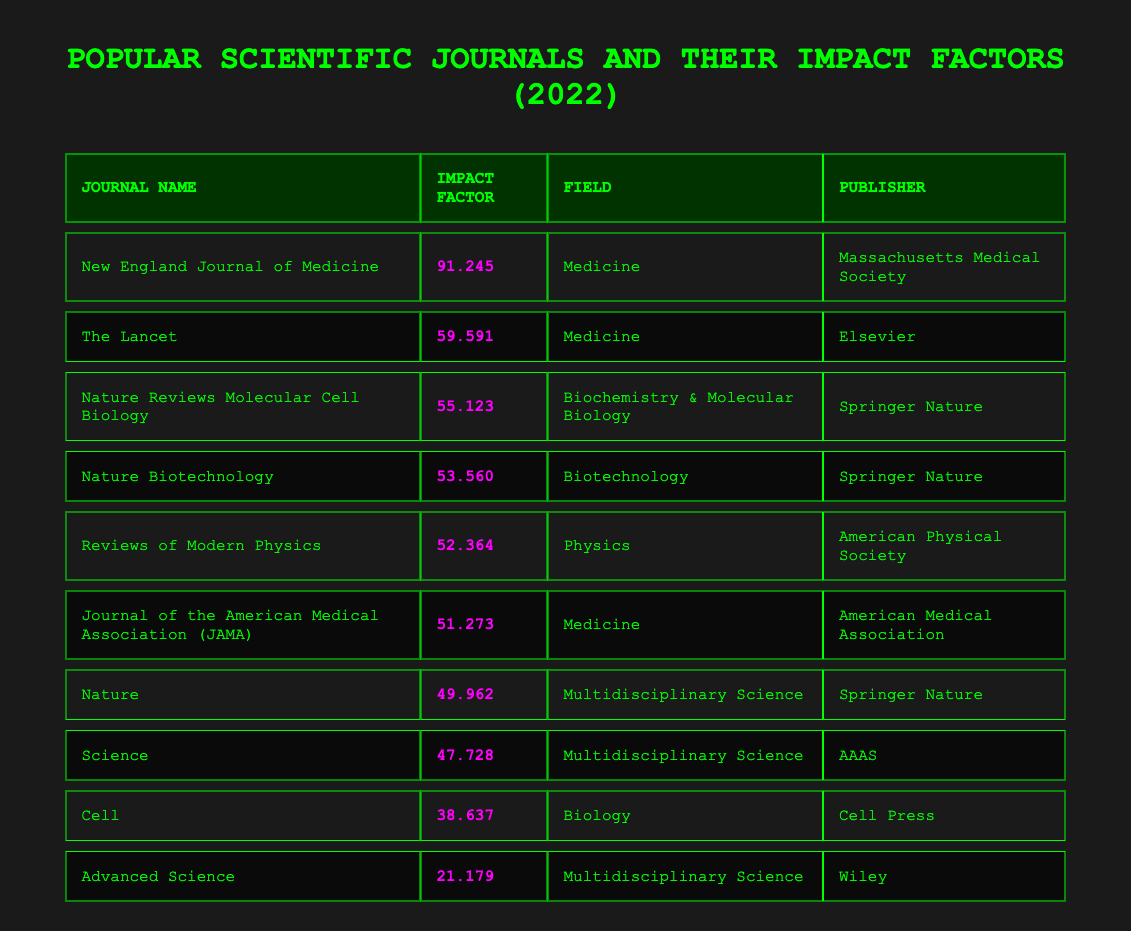What is the impact factor of The Lancet? The table shows that The Lancet has an impact factor listed next to its name. That value is 59.591 according to the table.
Answer: 59.591 Which journal has the highest impact factor in the Medicine field? By reviewing the impact factors under the Medicine field, the New England Journal of Medicine has the highest value of 91.245 among the listed journals.
Answer: New England Journal of Medicine How many journals have an impact factor above 50? Looking through the impact factors, the journals with impact factors above 50 are The Lancet, New England Journal of Medicine, Nature Reviews Molecular Cell Biology, Nature Biotechnology, and Reviews of Modern Physics. In total, there are 5 journals.
Answer: 5 What is the impact factor of Advanced Science? The table indicates that Advanced Science has an impact factor of 21.179 listed next to its name.
Answer: 21.179 Is the impact factor of Cell greater than 40? The table shows that Cell has an impact factor of 38.637, which is less than 40. Therefore, the answer is no.
Answer: No What is the difference in impact factor between the journal with the highest impact factor and the journal with the lowest impact factor? The highest impact factor is for the New England Journal of Medicine at 91.245, and the lowest is for Advanced Science at 21.179. The difference is calculated as 91.245 - 21.179 = 70.066.
Answer: 70.066 Which field has the highest impact factor journal? Observing the fields and their highest journals, we identify that the Medicine field has the highest impact factor journal, the New England Journal of Medicine, with a value of 91.245.
Answer: Medicine What is the average impact factor of journals listed under Multidisciplinary Science? The impact factors for the Multidisciplinary Science journals, Nature (49.962), Science (47.728), and Advanced Science (21.179), total 49.962 + 47.728 + 21.179 = 118.869. Since there are 3 journals, the average is 118.869 / 3 = 39.623.
Answer: 39.623 Does Nature Biotechnology have a lower impact factor than JAMA? The impact factor of Nature Biotechnology is 53.560, while JAMA has an impact factor of 51.273. Since 53.560 is greater than 51.273, the answer is no.
Answer: No How many publishers are represented in this table? The table lists 8 journals, each with a unique publisher. By examining the publisher names, we find that there are 6 distinct publishers: Springer Nature, AAAS, Elsevier, American Medical Association, Massachusetts Medical Society, and Wiley.
Answer: 6 